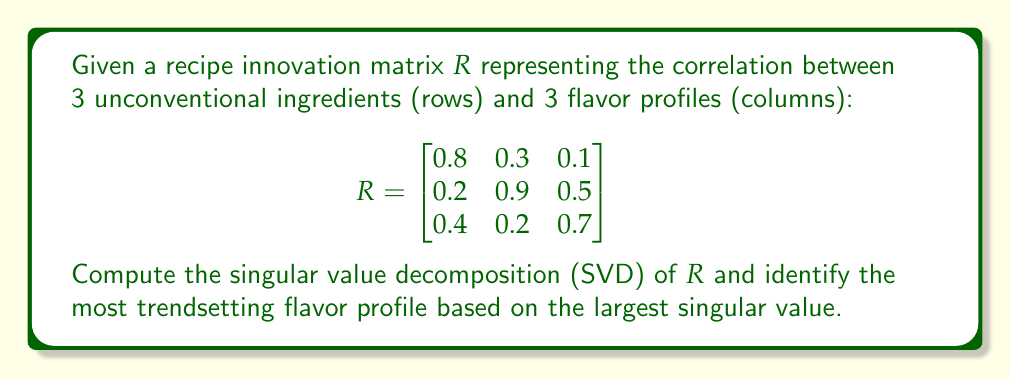Can you answer this question? To compute the SVD of matrix $R$, we follow these steps:

1) Calculate $R^TR$ and $RR^T$:

$$R^TR = \begin{bmatrix}
0.84 & 0.51 & 0.43 \\
0.51 & 0.94 & 0.49 \\
0.43 & 0.49 & 0.75
\end{bmatrix}$$

$$RR^T = \begin{bmatrix}
0.74 & 0.45 & 0.38 \\
0.45 & 1.15 & 0.59 \\
0.38 & 0.59 & 0.69
\end{bmatrix}$$

2) Find eigenvalues of $R^TR$ (same as singular values squared):
   Characteristic equation: $\det(R^TR - \lambda I) = 0$
   Solving this yields: $\lambda_1 \approx 1.8858$, $\lambda_2 \approx 0.5654$, $\lambda_3 \approx 0.0488$

3) Singular values are square roots of these eigenvalues:
   $\sigma_1 \approx 1.3733$, $\sigma_2 \approx 0.7519$, $\sigma_3 \approx 0.2209$

4) Find right singular vectors (eigenvectors of $R^TR$):
   Solving $(R^TR - \lambda_i I)v_i = 0$ for each $\lambda_i$
   After normalization:
   $v_1 \approx [0.4570, 0.7016, 0.5466]^T$
   $v_2 \approx [-0.8290, 0.3657, 0.4232]^T$
   $v_3 \approx [0.3236, -0.6113, 0.7228]^T$

5) Find left singular vectors:
   $u_i = \frac{1}{\sigma_i}Rv_i$ for each $i$
   After calculation and normalization:
   $u_1 \approx [0.3935, 0.7604, 0.5158]^T$
   $u_2 \approx [-0.7707, 0.5655, 0.2938]^T$
   $u_3 \approx [0.5000, -0.3203, 0.8047]^T$

6) The SVD of $R$ is:
   $R = U\Sigma V^T$
   where $U = [u_1 | u_2 | u_3]$, $V = [v_1 | v_2 | v_3]$, and
   $\Sigma = \text{diag}(\sigma_1, \sigma_2, \sigma_3)$

7) The largest singular value is $\sigma_1 \approx 1.3733$, corresponding to the right singular vector $v_1 \approx [0.4570, 0.7016, 0.5466]^T$

8) The component with the largest magnitude in $v_1$ is the second one (0.7016), corresponding to the second column of the original matrix $R$. This represents the most trendsetting flavor profile.
Answer: The second flavor profile is the most trendsetting, corresponding to the largest component (0.7016) of the first right singular vector. 